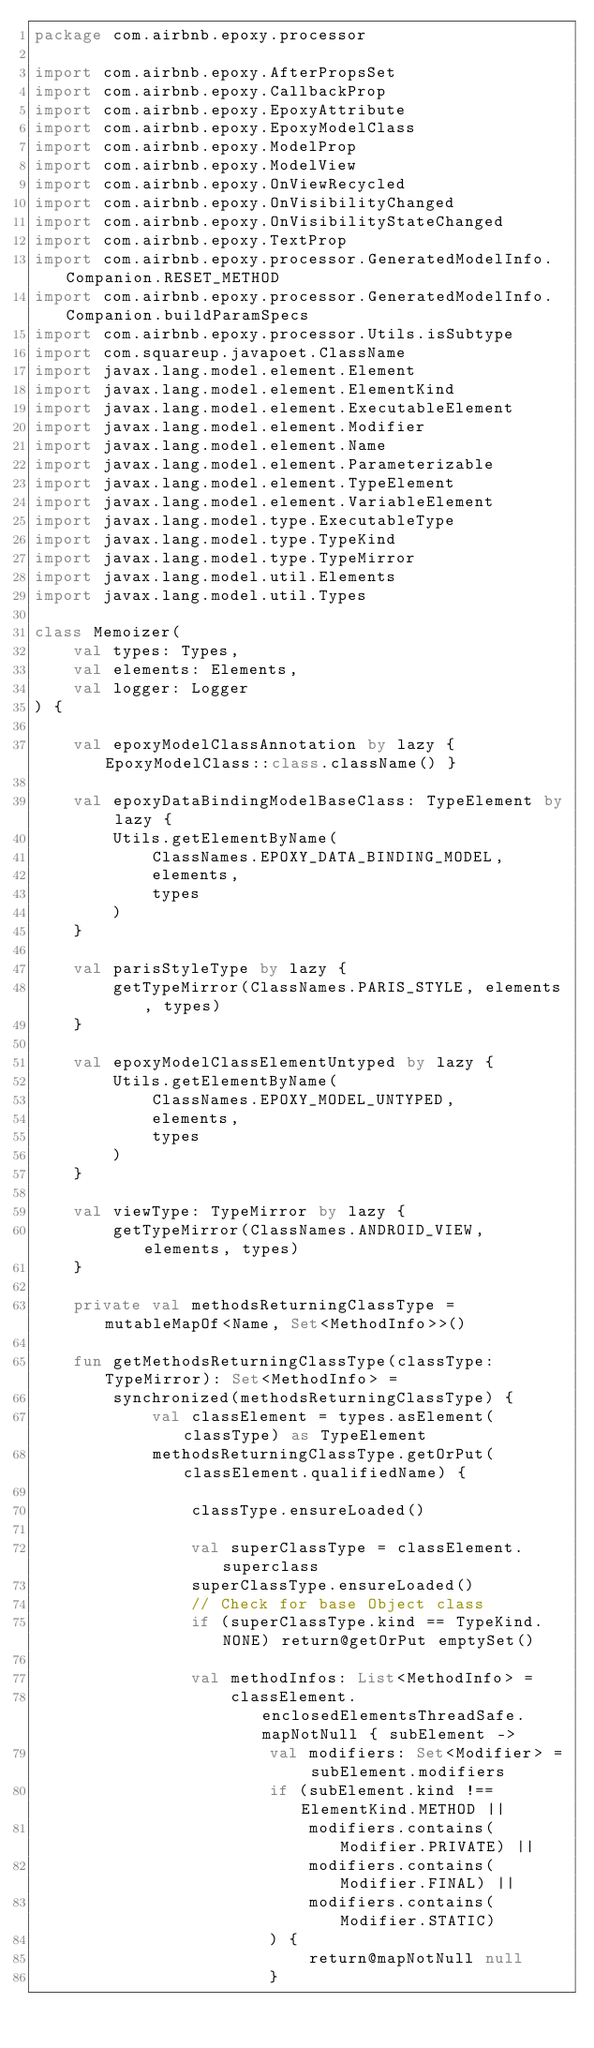Convert code to text. <code><loc_0><loc_0><loc_500><loc_500><_Kotlin_>package com.airbnb.epoxy.processor

import com.airbnb.epoxy.AfterPropsSet
import com.airbnb.epoxy.CallbackProp
import com.airbnb.epoxy.EpoxyAttribute
import com.airbnb.epoxy.EpoxyModelClass
import com.airbnb.epoxy.ModelProp
import com.airbnb.epoxy.ModelView
import com.airbnb.epoxy.OnViewRecycled
import com.airbnb.epoxy.OnVisibilityChanged
import com.airbnb.epoxy.OnVisibilityStateChanged
import com.airbnb.epoxy.TextProp
import com.airbnb.epoxy.processor.GeneratedModelInfo.Companion.RESET_METHOD
import com.airbnb.epoxy.processor.GeneratedModelInfo.Companion.buildParamSpecs
import com.airbnb.epoxy.processor.Utils.isSubtype
import com.squareup.javapoet.ClassName
import javax.lang.model.element.Element
import javax.lang.model.element.ElementKind
import javax.lang.model.element.ExecutableElement
import javax.lang.model.element.Modifier
import javax.lang.model.element.Name
import javax.lang.model.element.Parameterizable
import javax.lang.model.element.TypeElement
import javax.lang.model.element.VariableElement
import javax.lang.model.type.ExecutableType
import javax.lang.model.type.TypeKind
import javax.lang.model.type.TypeMirror
import javax.lang.model.util.Elements
import javax.lang.model.util.Types

class Memoizer(
    val types: Types,
    val elements: Elements,
    val logger: Logger
) {

    val epoxyModelClassAnnotation by lazy { EpoxyModelClass::class.className() }

    val epoxyDataBindingModelBaseClass: TypeElement by lazy {
        Utils.getElementByName(
            ClassNames.EPOXY_DATA_BINDING_MODEL,
            elements,
            types
        )
    }

    val parisStyleType by lazy {
        getTypeMirror(ClassNames.PARIS_STYLE, elements, types)
    }

    val epoxyModelClassElementUntyped by lazy {
        Utils.getElementByName(
            ClassNames.EPOXY_MODEL_UNTYPED,
            elements,
            types
        )
    }

    val viewType: TypeMirror by lazy {
        getTypeMirror(ClassNames.ANDROID_VIEW, elements, types)
    }

    private val methodsReturningClassType = mutableMapOf<Name, Set<MethodInfo>>()

    fun getMethodsReturningClassType(classType: TypeMirror): Set<MethodInfo> =
        synchronized(methodsReturningClassType) {
            val classElement = types.asElement(classType) as TypeElement
            methodsReturningClassType.getOrPut(classElement.qualifiedName) {

                classType.ensureLoaded()

                val superClassType = classElement.superclass
                superClassType.ensureLoaded()
                // Check for base Object class
                if (superClassType.kind == TypeKind.NONE) return@getOrPut emptySet()

                val methodInfos: List<MethodInfo> =
                    classElement.enclosedElementsThreadSafe.mapNotNull { subElement ->
                        val modifiers: Set<Modifier> = subElement.modifiers
                        if (subElement.kind !== ElementKind.METHOD ||
                            modifiers.contains(Modifier.PRIVATE) ||
                            modifiers.contains(Modifier.FINAL) ||
                            modifiers.contains(Modifier.STATIC)
                        ) {
                            return@mapNotNull null
                        }
</code> 